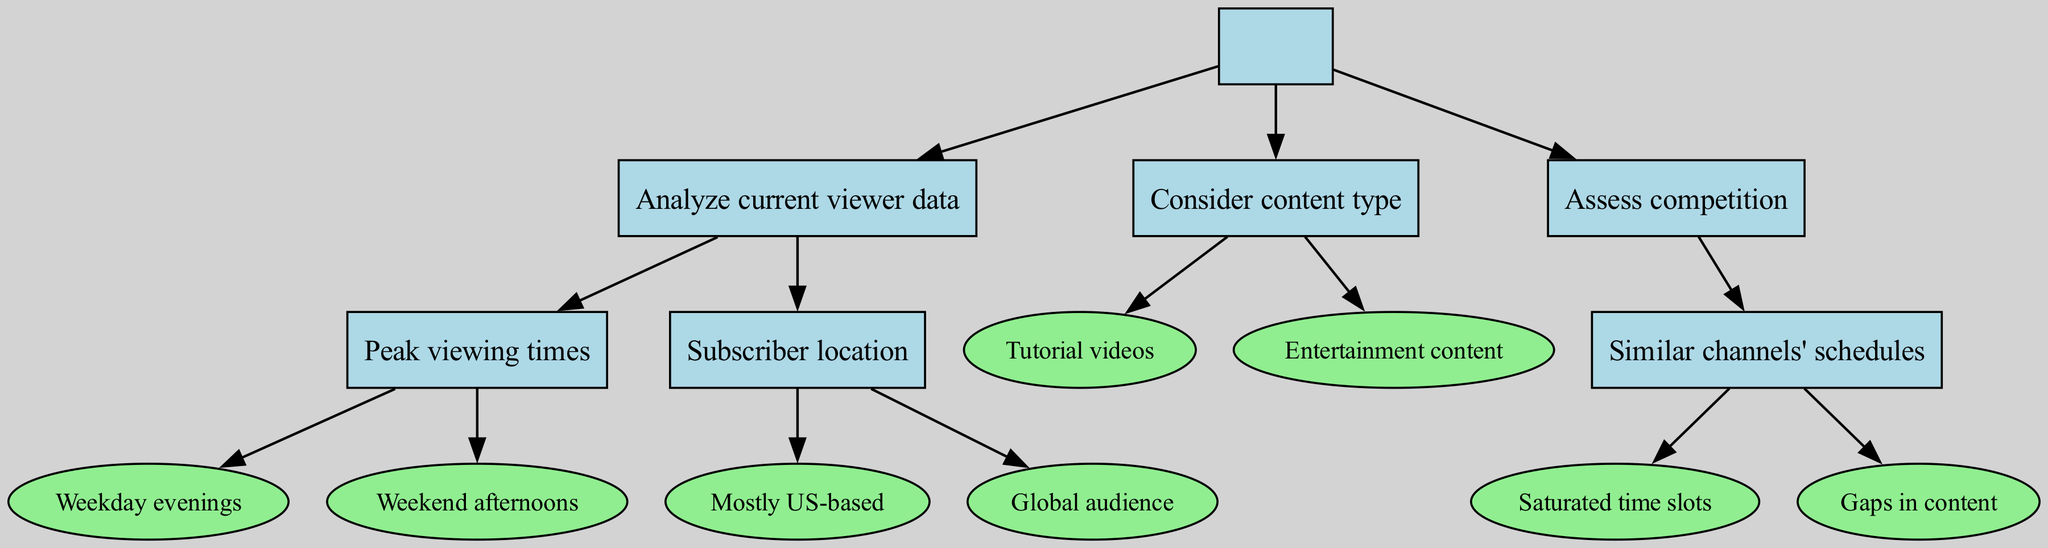What is the root node of this diagram? The root node is the top-most node that represents the primary goal of the tree, which is to "Determine optimal upload schedule."
Answer: Determine optimal upload schedule How many main branches are there from the root node? There are three main branches under the root node, which are "Analyze current viewer data," "Consider content type," and "Assess competition."
Answer: 3 What is the result for 'Peak viewing times' on weekday evenings? The result for 'Peak viewing times' on weekday evenings is to "Schedule uploads for 6-8 PM."
Answer: Schedule uploads for 6-8 PM What is recommended if the audience is "Mostly US-based"? The recommendation for an audience that is "Mostly US-based" is to "Align with US time zones."
Answer: Align with US time zones If the content type is "Tutorial videos," when should uploads be made? For "Tutorial videos," the diagram suggests that uploads should be done "mid-week for weekend projects."
Answer: mid-week for weekend projects What action is recommended if similar channels have saturated time slots? The recommended action for similar channels having saturated time slots is to "Find less competitive times."
Answer: Find less competitive times What should be done if there are gaps in content from similar channels? If there are gaps in content from similar channels, the action to take is to "Fill empty slots in schedule."
Answer: Fill empty slots in schedule Which time is suggested for uploading entertainment content? The suggested time for uploading entertainment content is "on Fridays for weekend viewing."
Answer: on Fridays for weekend viewing What is the outcome if the audience is global and diverse? If the audience is global, the outcome is to "Stagger uploads for different time zones."
Answer: Stagger uploads for different time zones 